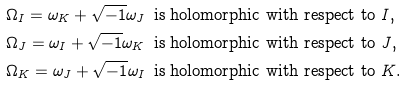Convert formula to latex. <formula><loc_0><loc_0><loc_500><loc_500>\Omega _ { I } = \omega _ { K } + \sqrt { - 1 } \omega _ { J } & \, \text { is holomorphic with respect to $I$,} \\ \Omega _ { J } = \omega _ { I } + \sqrt { - 1 } \omega _ { K } & \, \text { is holomorphic with respect to $J$,} \\ \Omega _ { K } = \omega _ { J } + \sqrt { - 1 } \omega _ { I } & \, \text { is holomorphic with respect to $K$.}</formula> 